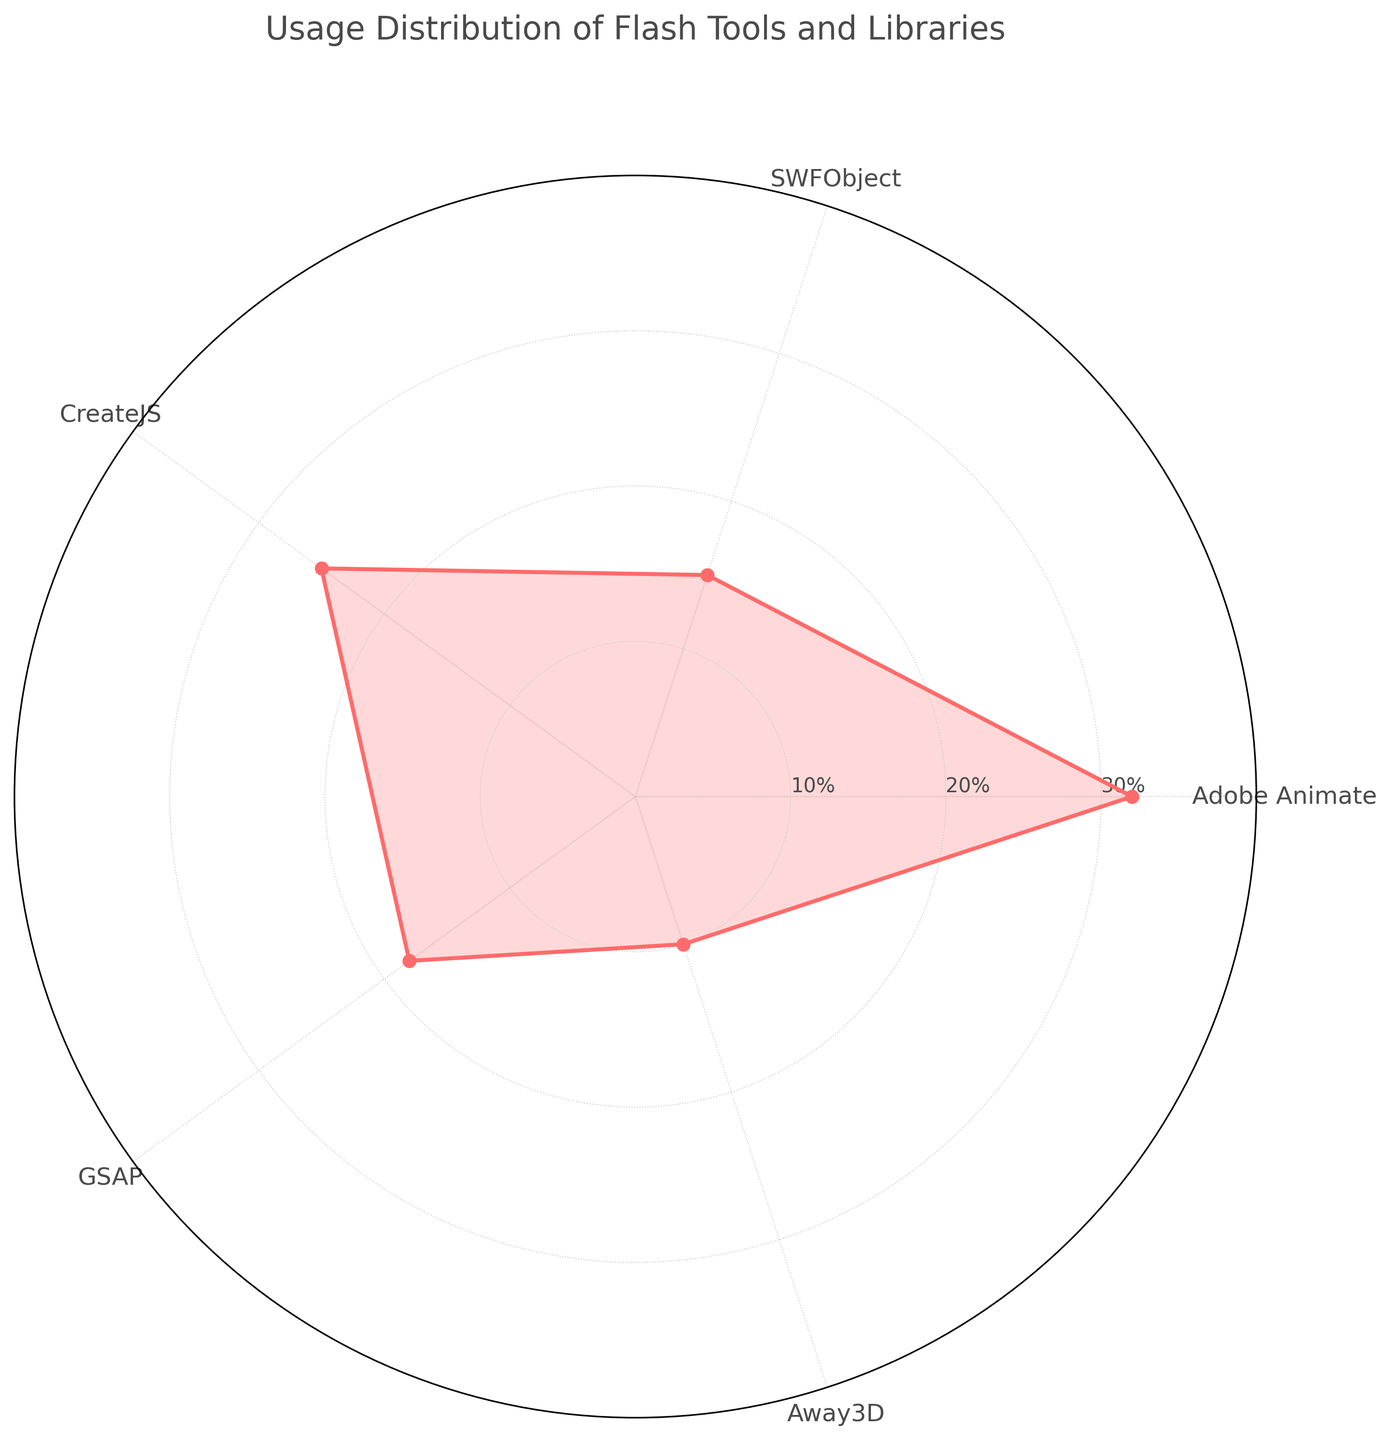What is the title of the radar chart? The title is written at the top of the radar chart, above the plot area. It states the overall topic that the chart is about.
Answer: Usage Distribution of Flash Tools and Libraries How many tools and libraries are analyzed in the chart? The radar chart has categories labeled around its perimeter. Each label represents one tool or library analyzed in the chart.
Answer: 5 Which tool has the highest usage percentage? By observing the outermost point on the radar chart, we see which tool's data point extends the furthest from the center. The longest segment represents the tool with the highest usage.
Answer: Adobe Animate What is the average usage percentage of all the tools and libraries combined? To find the average, sum up all the usage percentages and divide by the number of tools. Calculation: (32 + 15 + 25 + 18 + 10) / 5 = 100 / 5 = 20
Answer: 20% Which tool has the lowest usage percentage? On the radar chart, the tool with the innermost data point closest to the center represents the lowest percentage of usage.
Answer: Away3D How much higher is Adobe Animate's usage compared to Away3D's usage? Subtract Away3D's usage percentage from Adobe Animate's usage percentage. Calculation: 32 - 10 = 22
Answer: 22% Is the usage of CreateJS equal to, greater than, or less than the usage of GSAP? Compare the points for CreateJS and GSAP on the radar chart. CreateJS's point is further from the center than GSAP's.
Answer: Greater than How does SWFObject's usage compare to the average usage percentage? First, determine the average usage (previously calculated as 20%). Then compare SWFObject's usage to the average. 15% is less than 20%.
Answer: Less than If the usage of all tools were evenly distributed, what would be the percentage usage for each tool? Even distribution means the total usage (100%) would be divided equally among all tools. Calculation: 100% / 5 = 20%
Answer: 20% What is the difference between the highest and the lowest usage percentages? Subtract the lowest usage percentage from the highest usage percentage. Calculation: 32% (Adobe Animate) - 10% (Away3D) = 22%
Answer: 22% 